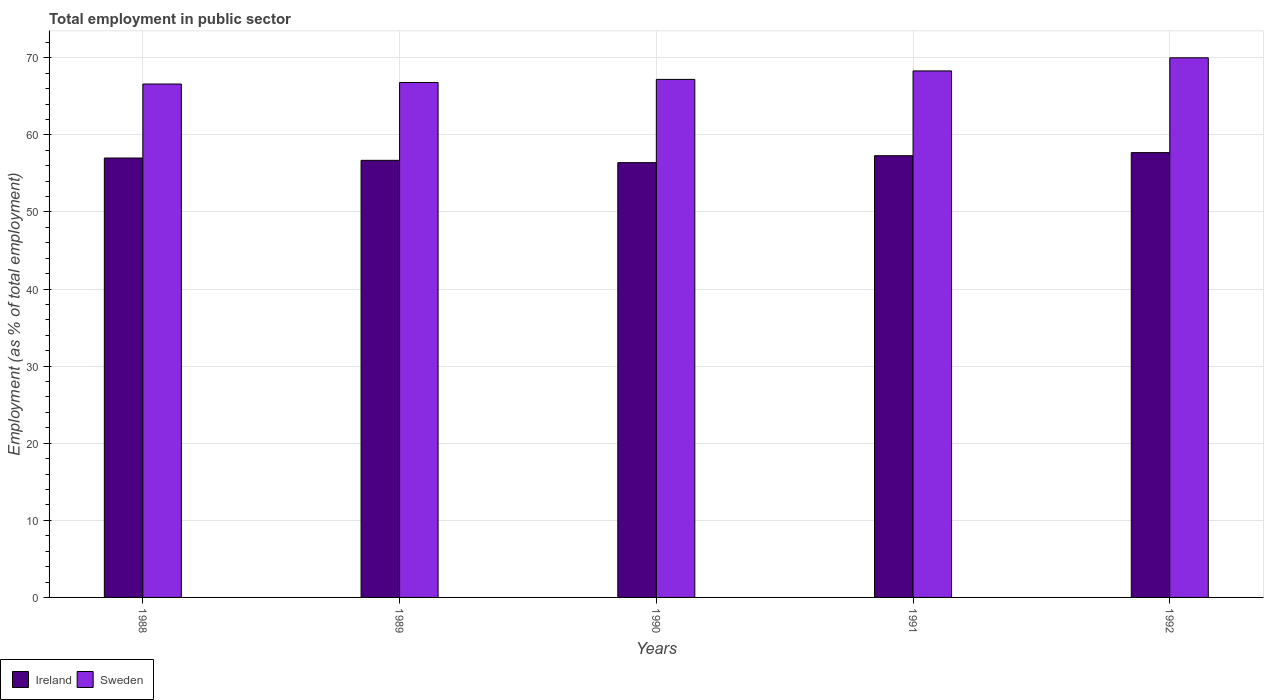How many different coloured bars are there?
Ensure brevity in your answer.  2. Are the number of bars per tick equal to the number of legend labels?
Keep it short and to the point. Yes. How many bars are there on the 4th tick from the left?
Give a very brief answer. 2. How many bars are there on the 2nd tick from the right?
Offer a very short reply. 2. What is the label of the 3rd group of bars from the left?
Your response must be concise. 1990. What is the employment in public sector in Ireland in 1992?
Offer a terse response. 57.7. Across all years, what is the minimum employment in public sector in Ireland?
Make the answer very short. 56.4. In which year was the employment in public sector in Sweden minimum?
Provide a succinct answer. 1988. What is the total employment in public sector in Sweden in the graph?
Provide a short and direct response. 338.9. What is the difference between the employment in public sector in Sweden in 1990 and that in 1991?
Ensure brevity in your answer.  -1.1. What is the difference between the employment in public sector in Sweden in 1991 and the employment in public sector in Ireland in 1990?
Provide a succinct answer. 11.9. What is the average employment in public sector in Ireland per year?
Your answer should be compact. 57.02. In the year 1989, what is the difference between the employment in public sector in Ireland and employment in public sector in Sweden?
Provide a short and direct response. -10.1. What is the ratio of the employment in public sector in Sweden in 1991 to that in 1992?
Ensure brevity in your answer.  0.98. What is the difference between the highest and the second highest employment in public sector in Sweden?
Keep it short and to the point. 1.7. What is the difference between the highest and the lowest employment in public sector in Sweden?
Give a very brief answer. 3.4. Is the sum of the employment in public sector in Ireland in 1988 and 1990 greater than the maximum employment in public sector in Sweden across all years?
Provide a succinct answer. Yes. What is the difference between two consecutive major ticks on the Y-axis?
Give a very brief answer. 10. Where does the legend appear in the graph?
Your response must be concise. Bottom left. What is the title of the graph?
Your response must be concise. Total employment in public sector. Does "Netherlands" appear as one of the legend labels in the graph?
Offer a terse response. No. What is the label or title of the X-axis?
Provide a succinct answer. Years. What is the label or title of the Y-axis?
Your answer should be compact. Employment (as % of total employment). What is the Employment (as % of total employment) of Sweden in 1988?
Your answer should be very brief. 66.6. What is the Employment (as % of total employment) in Ireland in 1989?
Offer a very short reply. 56.7. What is the Employment (as % of total employment) of Sweden in 1989?
Keep it short and to the point. 66.8. What is the Employment (as % of total employment) of Ireland in 1990?
Provide a succinct answer. 56.4. What is the Employment (as % of total employment) in Sweden in 1990?
Provide a succinct answer. 67.2. What is the Employment (as % of total employment) in Ireland in 1991?
Give a very brief answer. 57.3. What is the Employment (as % of total employment) of Sweden in 1991?
Make the answer very short. 68.3. What is the Employment (as % of total employment) of Ireland in 1992?
Your response must be concise. 57.7. What is the Employment (as % of total employment) in Sweden in 1992?
Offer a very short reply. 70. Across all years, what is the maximum Employment (as % of total employment) in Ireland?
Make the answer very short. 57.7. Across all years, what is the maximum Employment (as % of total employment) of Sweden?
Offer a terse response. 70. Across all years, what is the minimum Employment (as % of total employment) of Ireland?
Offer a very short reply. 56.4. Across all years, what is the minimum Employment (as % of total employment) in Sweden?
Your response must be concise. 66.6. What is the total Employment (as % of total employment) in Ireland in the graph?
Ensure brevity in your answer.  285.1. What is the total Employment (as % of total employment) in Sweden in the graph?
Keep it short and to the point. 338.9. What is the difference between the Employment (as % of total employment) in Sweden in 1988 and that in 1989?
Ensure brevity in your answer.  -0.2. What is the difference between the Employment (as % of total employment) of Ireland in 1988 and that in 1990?
Provide a short and direct response. 0.6. What is the difference between the Employment (as % of total employment) in Sweden in 1988 and that in 1990?
Your response must be concise. -0.6. What is the difference between the Employment (as % of total employment) in Ireland in 1988 and that in 1992?
Your answer should be very brief. -0.7. What is the difference between the Employment (as % of total employment) of Sweden in 1988 and that in 1992?
Offer a terse response. -3.4. What is the difference between the Employment (as % of total employment) in Sweden in 1989 and that in 1990?
Your answer should be compact. -0.4. What is the difference between the Employment (as % of total employment) in Ireland in 1989 and that in 1991?
Your response must be concise. -0.6. What is the difference between the Employment (as % of total employment) in Ireland in 1989 and that in 1992?
Offer a very short reply. -1. What is the difference between the Employment (as % of total employment) in Sweden in 1989 and that in 1992?
Offer a very short reply. -3.2. What is the difference between the Employment (as % of total employment) in Ireland in 1990 and that in 1991?
Keep it short and to the point. -0.9. What is the difference between the Employment (as % of total employment) in Ireland in 1989 and the Employment (as % of total employment) in Sweden in 1990?
Your response must be concise. -10.5. What is the difference between the Employment (as % of total employment) of Ireland in 1989 and the Employment (as % of total employment) of Sweden in 1991?
Your answer should be very brief. -11.6. What is the difference between the Employment (as % of total employment) of Ireland in 1990 and the Employment (as % of total employment) of Sweden in 1991?
Ensure brevity in your answer.  -11.9. What is the difference between the Employment (as % of total employment) of Ireland in 1990 and the Employment (as % of total employment) of Sweden in 1992?
Provide a succinct answer. -13.6. What is the average Employment (as % of total employment) of Ireland per year?
Your answer should be very brief. 57.02. What is the average Employment (as % of total employment) of Sweden per year?
Make the answer very short. 67.78. In the year 1990, what is the difference between the Employment (as % of total employment) in Ireland and Employment (as % of total employment) in Sweden?
Provide a short and direct response. -10.8. What is the ratio of the Employment (as % of total employment) of Ireland in 1988 to that in 1990?
Provide a short and direct response. 1.01. What is the ratio of the Employment (as % of total employment) in Ireland in 1988 to that in 1991?
Your answer should be compact. 0.99. What is the ratio of the Employment (as % of total employment) of Sweden in 1988 to that in 1991?
Make the answer very short. 0.98. What is the ratio of the Employment (as % of total employment) of Ireland in 1988 to that in 1992?
Your answer should be compact. 0.99. What is the ratio of the Employment (as % of total employment) in Sweden in 1988 to that in 1992?
Provide a short and direct response. 0.95. What is the ratio of the Employment (as % of total employment) in Sweden in 1989 to that in 1990?
Your response must be concise. 0.99. What is the ratio of the Employment (as % of total employment) in Sweden in 1989 to that in 1991?
Your answer should be very brief. 0.98. What is the ratio of the Employment (as % of total employment) of Ireland in 1989 to that in 1992?
Your answer should be very brief. 0.98. What is the ratio of the Employment (as % of total employment) in Sweden in 1989 to that in 1992?
Make the answer very short. 0.95. What is the ratio of the Employment (as % of total employment) in Ireland in 1990 to that in 1991?
Offer a very short reply. 0.98. What is the ratio of the Employment (as % of total employment) in Sweden in 1990 to that in 1991?
Your answer should be very brief. 0.98. What is the ratio of the Employment (as % of total employment) in Ireland in 1990 to that in 1992?
Your answer should be very brief. 0.98. What is the ratio of the Employment (as % of total employment) in Ireland in 1991 to that in 1992?
Give a very brief answer. 0.99. What is the ratio of the Employment (as % of total employment) in Sweden in 1991 to that in 1992?
Your answer should be compact. 0.98. What is the difference between the highest and the second highest Employment (as % of total employment) in Ireland?
Offer a very short reply. 0.4. What is the difference between the highest and the second highest Employment (as % of total employment) of Sweden?
Offer a terse response. 1.7. What is the difference between the highest and the lowest Employment (as % of total employment) in Sweden?
Your answer should be very brief. 3.4. 